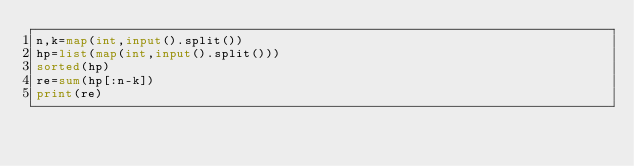<code> <loc_0><loc_0><loc_500><loc_500><_Python_>n,k=map(int,input().split())
hp=list(map(int,input().split()))
sorted(hp)
re=sum(hp[:n-k])
print(re)
</code> 